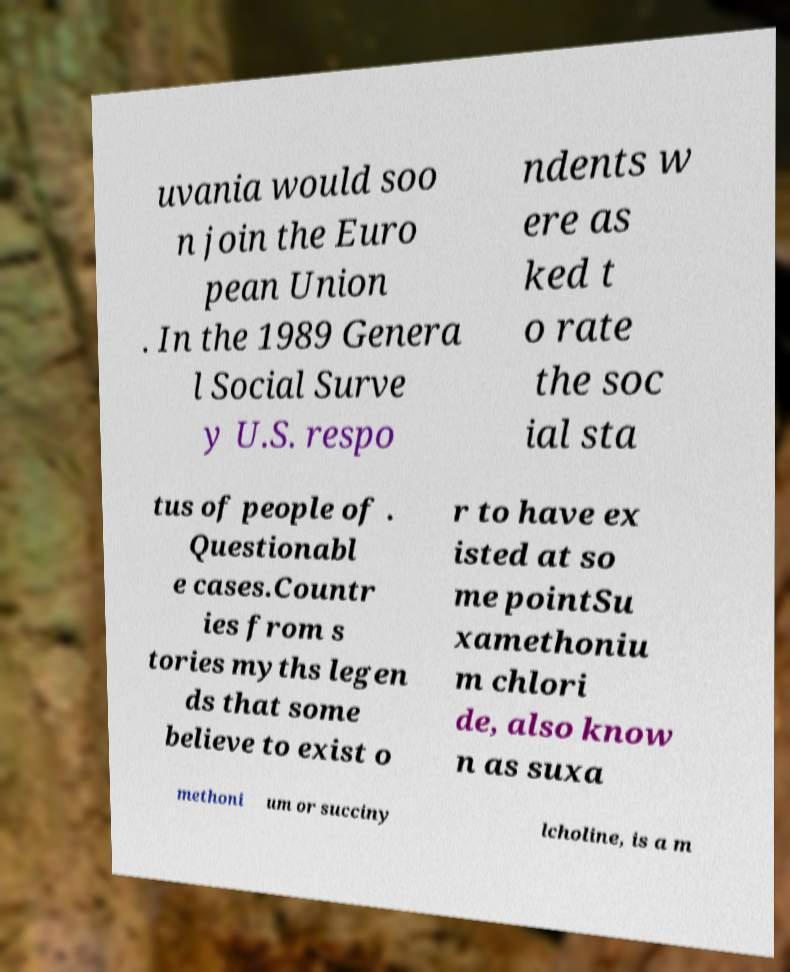For documentation purposes, I need the text within this image transcribed. Could you provide that? uvania would soo n join the Euro pean Union . In the 1989 Genera l Social Surve y U.S. respo ndents w ere as ked t o rate the soc ial sta tus of people of . Questionabl e cases.Countr ies from s tories myths legen ds that some believe to exist o r to have ex isted at so me pointSu xamethoniu m chlori de, also know n as suxa methoni um or succiny lcholine, is a m 